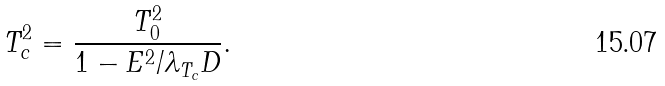<formula> <loc_0><loc_0><loc_500><loc_500>T ^ { 2 } _ { c } = \frac { T _ { 0 } ^ { 2 } } { 1 - E ^ { 2 } / \lambda _ { T _ { c } } D } .</formula> 